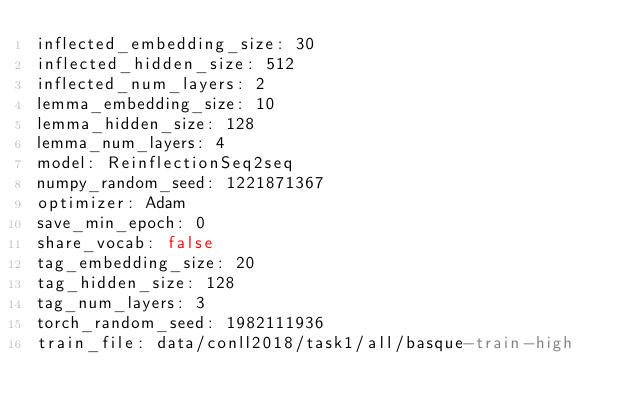Convert code to text. <code><loc_0><loc_0><loc_500><loc_500><_YAML_>inflected_embedding_size: 30
inflected_hidden_size: 512
inflected_num_layers: 2
lemma_embedding_size: 10
lemma_hidden_size: 128
lemma_num_layers: 4
model: ReinflectionSeq2seq
numpy_random_seed: 1221871367
optimizer: Adam
save_min_epoch: 0
share_vocab: false
tag_embedding_size: 20
tag_hidden_size: 128
tag_num_layers: 3
torch_random_seed: 1982111936
train_file: data/conll2018/task1/all/basque-train-high
</code> 